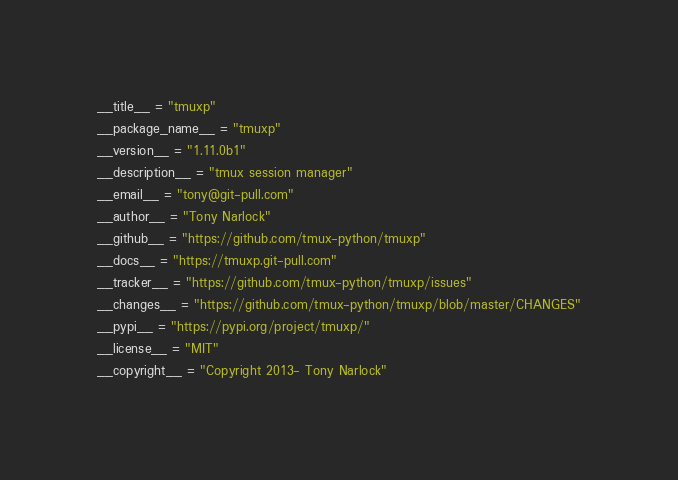<code> <loc_0><loc_0><loc_500><loc_500><_Python_>__title__ = "tmuxp"
__package_name__ = "tmuxp"
__version__ = "1.11.0b1"
__description__ = "tmux session manager"
__email__ = "tony@git-pull.com"
__author__ = "Tony Narlock"
__github__ = "https://github.com/tmux-python/tmuxp"
__docs__ = "https://tmuxp.git-pull.com"
__tracker__ = "https://github.com/tmux-python/tmuxp/issues"
__changes__ = "https://github.com/tmux-python/tmuxp/blob/master/CHANGES"
__pypi__ = "https://pypi.org/project/tmuxp/"
__license__ = "MIT"
__copyright__ = "Copyright 2013- Tony Narlock"
</code> 